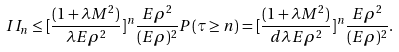Convert formula to latex. <formula><loc_0><loc_0><loc_500><loc_500>I I _ { n } \leq [ \frac { ( 1 + \lambda M ^ { 2 } ) } { \lambda E \rho ^ { 2 } } ] ^ { n } \frac { E \rho ^ { 2 } } { ( E \rho ) ^ { 2 } } P ( \tau \geq n ) = [ \frac { ( 1 + \lambda M ^ { 2 } ) } { d \lambda E \rho ^ { 2 } } ] ^ { n } \frac { E \rho ^ { 2 } } { ( E \rho ) ^ { 2 } } .</formula> 